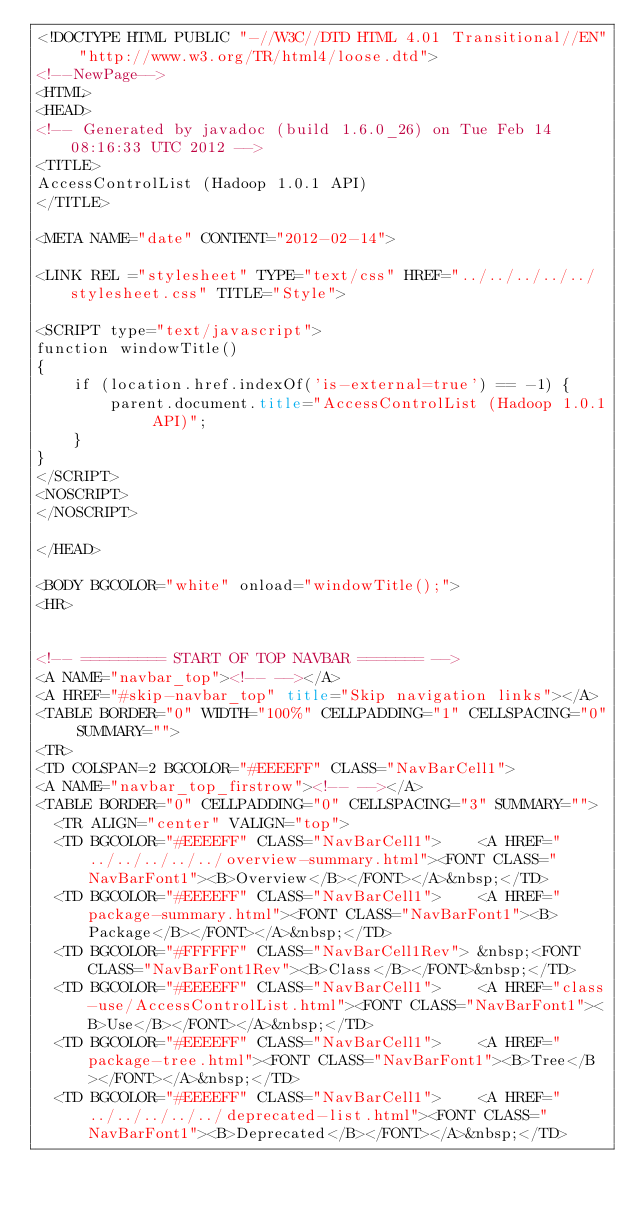<code> <loc_0><loc_0><loc_500><loc_500><_HTML_><!DOCTYPE HTML PUBLIC "-//W3C//DTD HTML 4.01 Transitional//EN" "http://www.w3.org/TR/html4/loose.dtd">
<!--NewPage-->
<HTML>
<HEAD>
<!-- Generated by javadoc (build 1.6.0_26) on Tue Feb 14 08:16:33 UTC 2012 -->
<TITLE>
AccessControlList (Hadoop 1.0.1 API)
</TITLE>

<META NAME="date" CONTENT="2012-02-14">

<LINK REL ="stylesheet" TYPE="text/css" HREF="../../../../../stylesheet.css" TITLE="Style">

<SCRIPT type="text/javascript">
function windowTitle()
{
    if (location.href.indexOf('is-external=true') == -1) {
        parent.document.title="AccessControlList (Hadoop 1.0.1 API)";
    }
}
</SCRIPT>
<NOSCRIPT>
</NOSCRIPT>

</HEAD>

<BODY BGCOLOR="white" onload="windowTitle();">
<HR>


<!-- ========= START OF TOP NAVBAR ======= -->
<A NAME="navbar_top"><!-- --></A>
<A HREF="#skip-navbar_top" title="Skip navigation links"></A>
<TABLE BORDER="0" WIDTH="100%" CELLPADDING="1" CELLSPACING="0" SUMMARY="">
<TR>
<TD COLSPAN=2 BGCOLOR="#EEEEFF" CLASS="NavBarCell1">
<A NAME="navbar_top_firstrow"><!-- --></A>
<TABLE BORDER="0" CELLPADDING="0" CELLSPACING="3" SUMMARY="">
  <TR ALIGN="center" VALIGN="top">
  <TD BGCOLOR="#EEEEFF" CLASS="NavBarCell1">    <A HREF="../../../../../overview-summary.html"><FONT CLASS="NavBarFont1"><B>Overview</B></FONT></A>&nbsp;</TD>
  <TD BGCOLOR="#EEEEFF" CLASS="NavBarCell1">    <A HREF="package-summary.html"><FONT CLASS="NavBarFont1"><B>Package</B></FONT></A>&nbsp;</TD>
  <TD BGCOLOR="#FFFFFF" CLASS="NavBarCell1Rev"> &nbsp;<FONT CLASS="NavBarFont1Rev"><B>Class</B></FONT>&nbsp;</TD>
  <TD BGCOLOR="#EEEEFF" CLASS="NavBarCell1">    <A HREF="class-use/AccessControlList.html"><FONT CLASS="NavBarFont1"><B>Use</B></FONT></A>&nbsp;</TD>
  <TD BGCOLOR="#EEEEFF" CLASS="NavBarCell1">    <A HREF="package-tree.html"><FONT CLASS="NavBarFont1"><B>Tree</B></FONT></A>&nbsp;</TD>
  <TD BGCOLOR="#EEEEFF" CLASS="NavBarCell1">    <A HREF="../../../../../deprecated-list.html"><FONT CLASS="NavBarFont1"><B>Deprecated</B></FONT></A>&nbsp;</TD></code> 